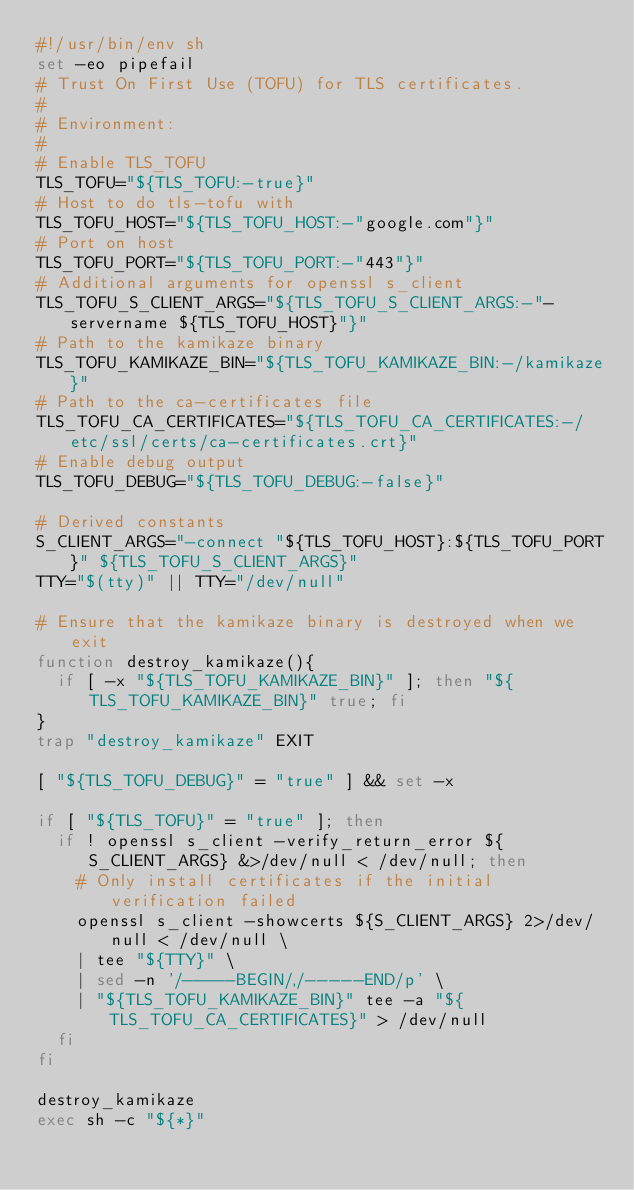Convert code to text. <code><loc_0><loc_0><loc_500><loc_500><_Bash_>#!/usr/bin/env sh
set -eo pipefail
# Trust On First Use (TOFU) for TLS certificates.
#
# Environment:
#
# Enable TLS_TOFU
TLS_TOFU="${TLS_TOFU:-true}"
# Host to do tls-tofu with
TLS_TOFU_HOST="${TLS_TOFU_HOST:-"google.com"}"
# Port on host
TLS_TOFU_PORT="${TLS_TOFU_PORT:-"443"}"
# Additional arguments for openssl s_client
TLS_TOFU_S_CLIENT_ARGS="${TLS_TOFU_S_CLIENT_ARGS:-"-servername ${TLS_TOFU_HOST}"}"
# Path to the kamikaze binary
TLS_TOFU_KAMIKAZE_BIN="${TLS_TOFU_KAMIKAZE_BIN:-/kamikaze}"
# Path to the ca-certificates file
TLS_TOFU_CA_CERTIFICATES="${TLS_TOFU_CA_CERTIFICATES:-/etc/ssl/certs/ca-certificates.crt}"
# Enable debug output
TLS_TOFU_DEBUG="${TLS_TOFU_DEBUG:-false}"

# Derived constants
S_CLIENT_ARGS="-connect "${TLS_TOFU_HOST}:${TLS_TOFU_PORT}" ${TLS_TOFU_S_CLIENT_ARGS}"
TTY="$(tty)" || TTY="/dev/null"

# Ensure that the kamikaze binary is destroyed when we exit
function destroy_kamikaze(){
  if [ -x "${TLS_TOFU_KAMIKAZE_BIN}" ]; then "${TLS_TOFU_KAMIKAZE_BIN}" true; fi
}
trap "destroy_kamikaze" EXIT

[ "${TLS_TOFU_DEBUG}" = "true" ] && set -x

if [ "${TLS_TOFU}" = "true" ]; then
  if ! openssl s_client -verify_return_error ${S_CLIENT_ARGS} &>/dev/null < /dev/null; then
    # Only install certificates if the initial verification failed
    openssl s_client -showcerts ${S_CLIENT_ARGS} 2>/dev/null < /dev/null \
    | tee "${TTY}" \
    | sed -n '/-----BEGIN/,/-----END/p' \
    | "${TLS_TOFU_KAMIKAZE_BIN}" tee -a "${TLS_TOFU_CA_CERTIFICATES}" > /dev/null
  fi
fi

destroy_kamikaze
exec sh -c "${*}"
</code> 